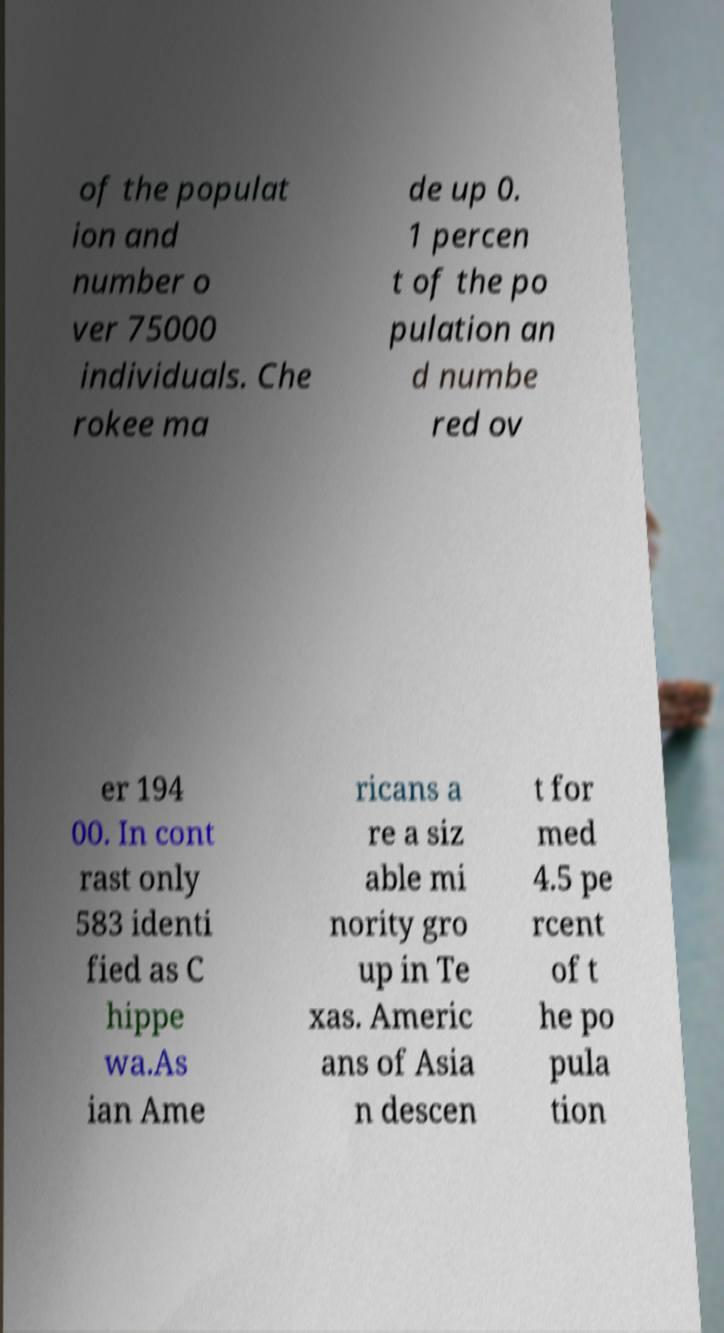Please identify and transcribe the text found in this image. of the populat ion and number o ver 75000 individuals. Che rokee ma de up 0. 1 percen t of the po pulation an d numbe red ov er 194 00. In cont rast only 583 identi fied as C hippe wa.As ian Ame ricans a re a siz able mi nority gro up in Te xas. Americ ans of Asia n descen t for med 4.5 pe rcent of t he po pula tion 